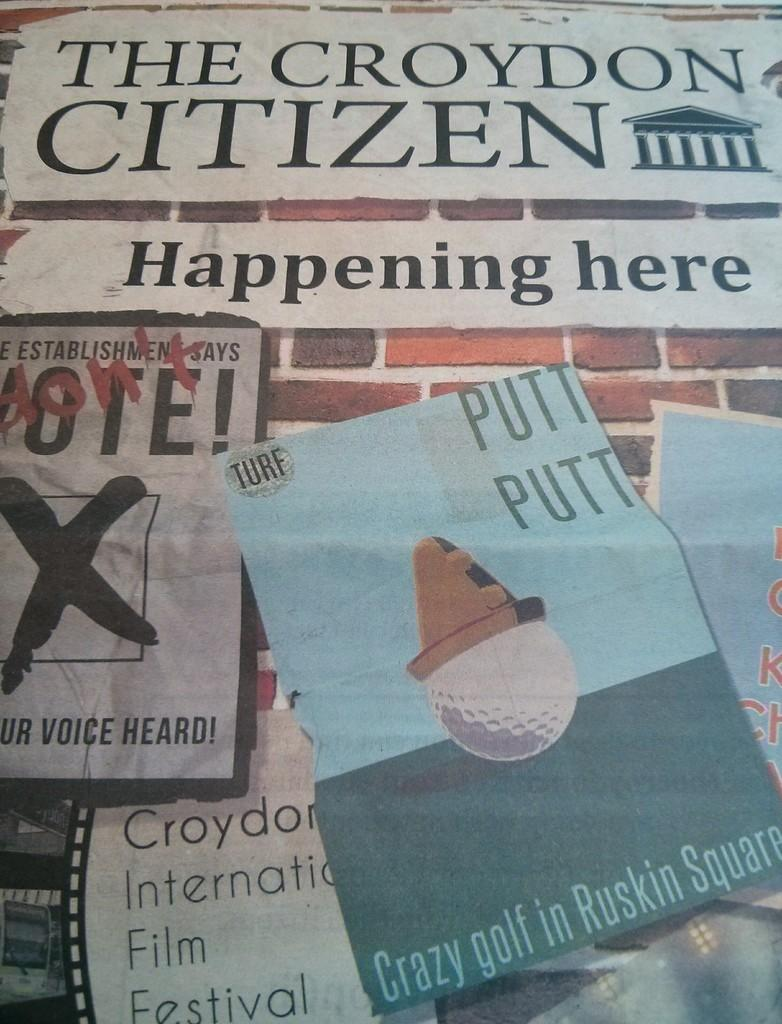What object can be seen in the image? There is a newspaper in the image. What is visible on the newspaper? There is writing on the newspaper. What shape is the experience taking in the image? There is no experience present in the image, as it only features a newspaper with writing on it. 